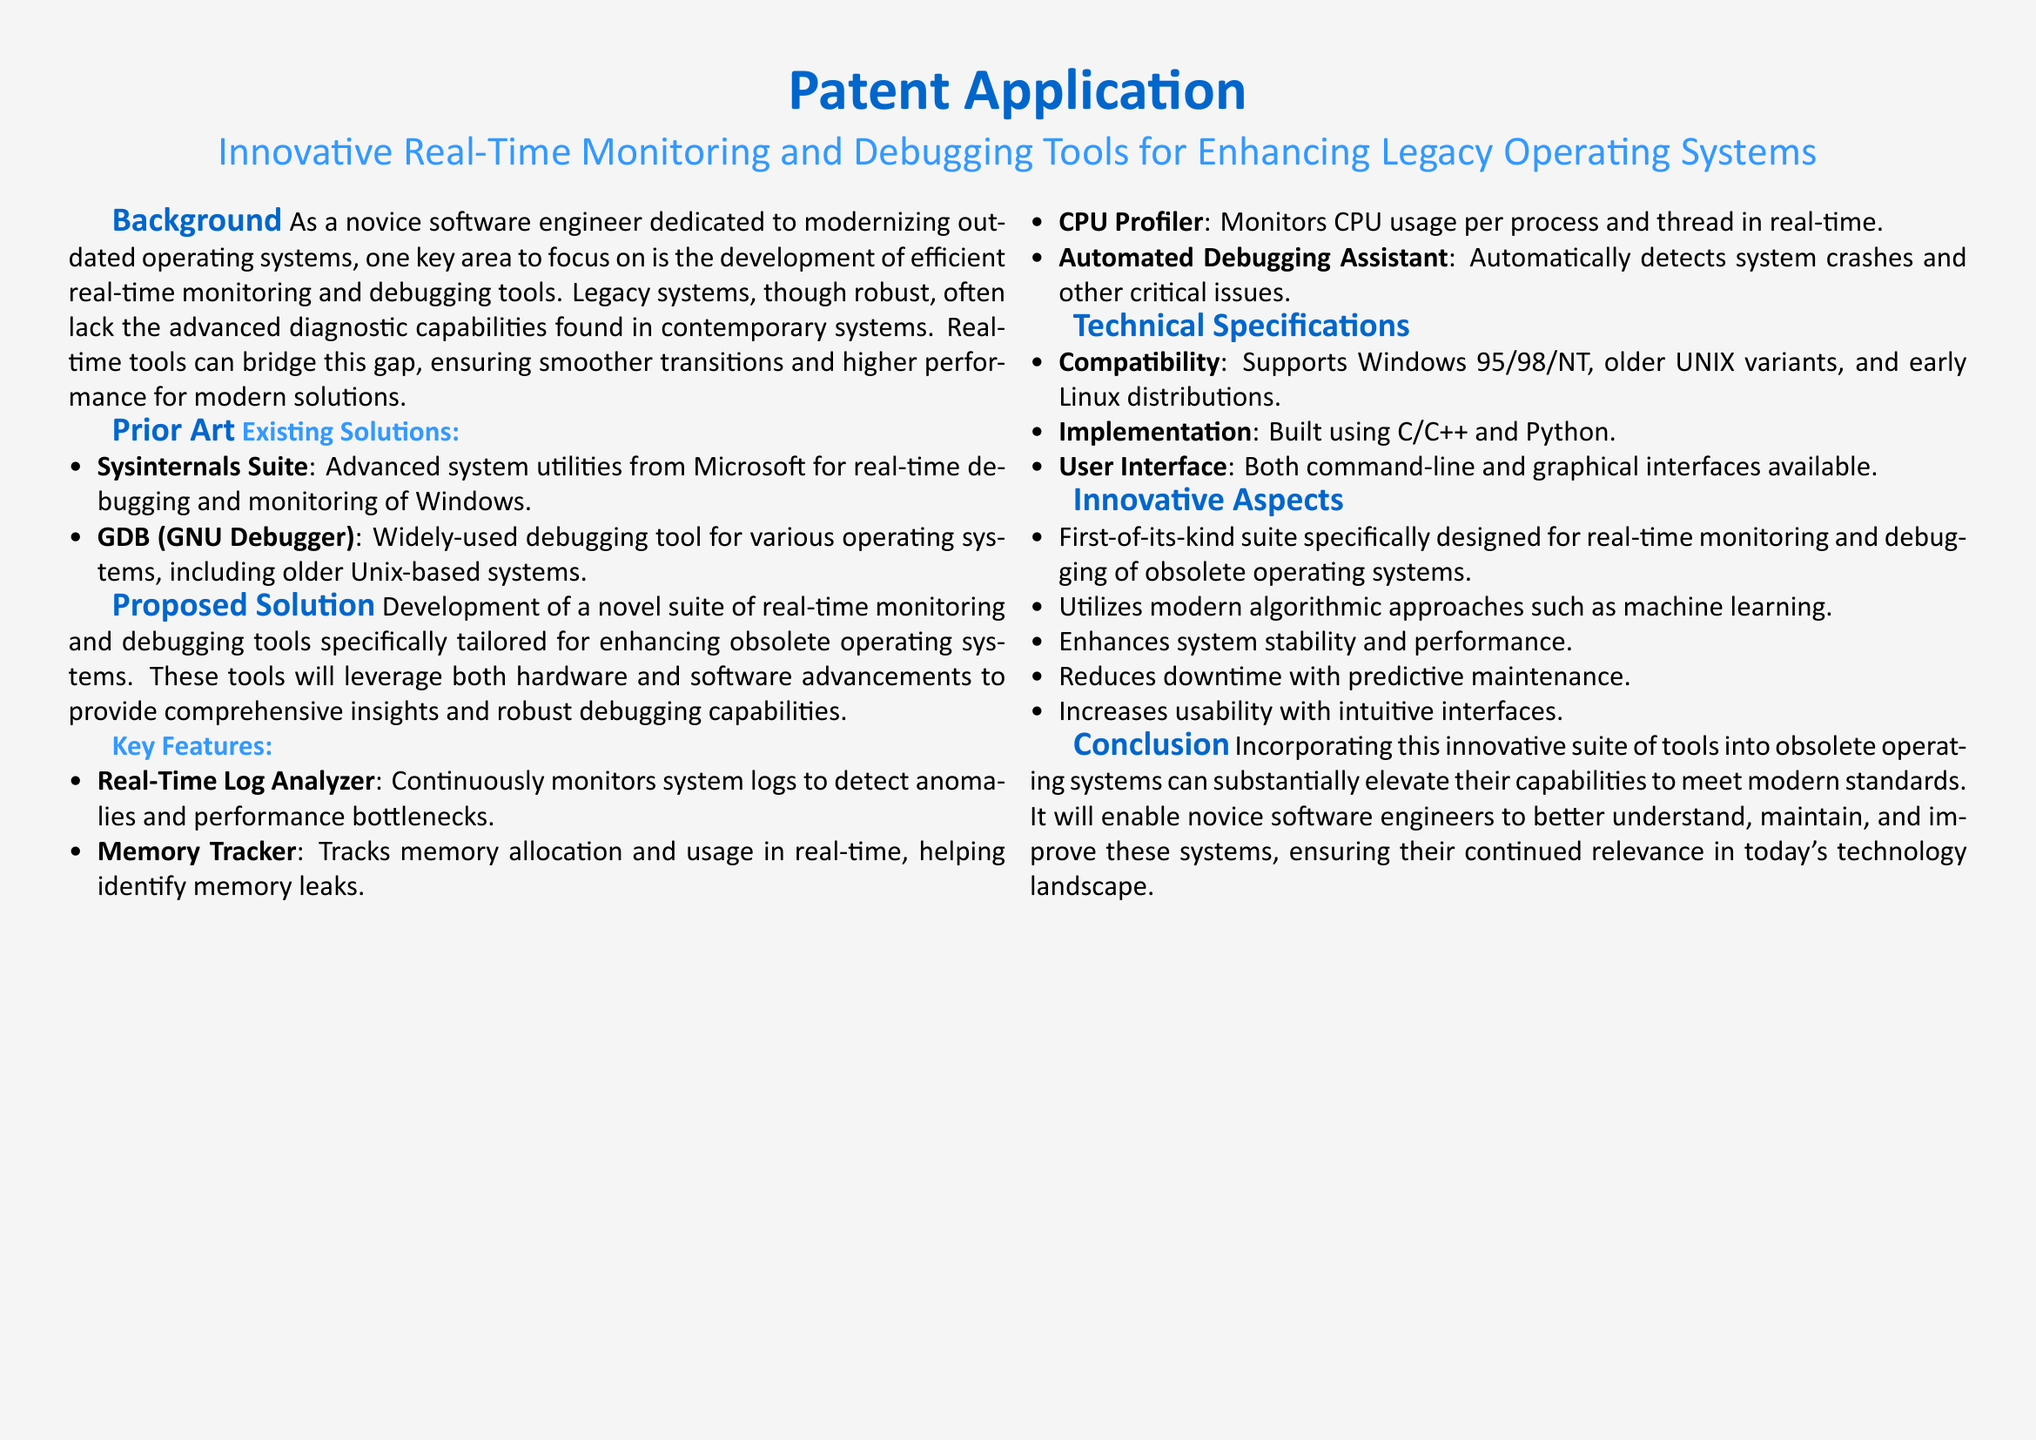What is the title of the patent application? The title of the patent application is stated in the document as "Innovative Real-Time Monitoring and Debugging Tools for Enhancing Legacy Operating Systems."
Answer: Innovative Real-Time Monitoring and Debugging Tools for Enhancing Legacy Operating Systems What systems does the proposed solution support? The compatibility section lists the supported systems, which include Windows 95/98/NT, older UNIX variants, and early Linux distributions.
Answer: Windows 95/98/NT, older UNIX variants, and early Linux distributions What is the first key feature mentioned? The key features section lists multiple tools, with the first feature being the Real-Time Log Analyzer.
Answer: Real-Time Log Analyzer How does the proposed solution aim to enhance system performance? The innovative aspects mention that it enhances system stability and performance, notably through predictive maintenance and modern algorithmic approaches.
Answer: Enhances system stability and performance What programming languages are used for implementation? The technical specifications section indicates that the tools are built using C/C++ and Python.
Answer: C/C++ and Python How many key features are outlined in the proposed solution? The number of items in the key features section provides the total, which is four listed features.
Answer: Four What is the main goal of the document? The conclusion states the purpose of incorporating the tools, which is to elevate the capabilities of obsolete operating systems to meet modern standards.
Answer: Elevate the capabilities of obsolete operating systems What type of user interface is mentioned? The technical specifications describe the user interface options, which include both command-line and graphical interfaces.
Answer: Command-line and graphical interfaces What is highlighted as the first innovative aspect of the proposed tools? The first innovative aspect states that it is the first-of-its-kind suite specifically designed for real-time monitoring and debugging of obsolete operating systems.
Answer: First-of-its-kind suite 